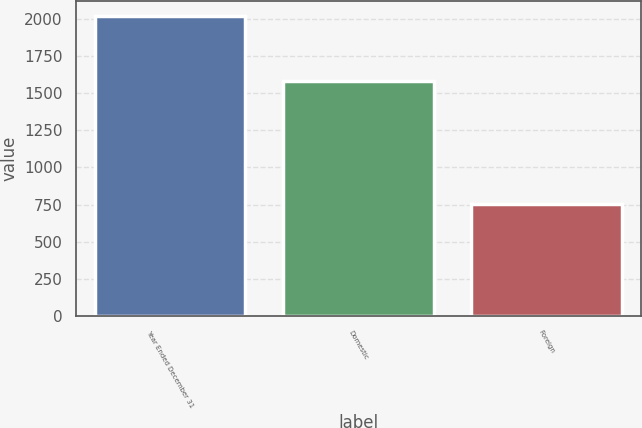Convert chart to OTSL. <chart><loc_0><loc_0><loc_500><loc_500><bar_chart><fcel>Year Ended December 31<fcel>Domestic<fcel>Foreign<nl><fcel>2015<fcel>1581.6<fcel>755.5<nl></chart> 